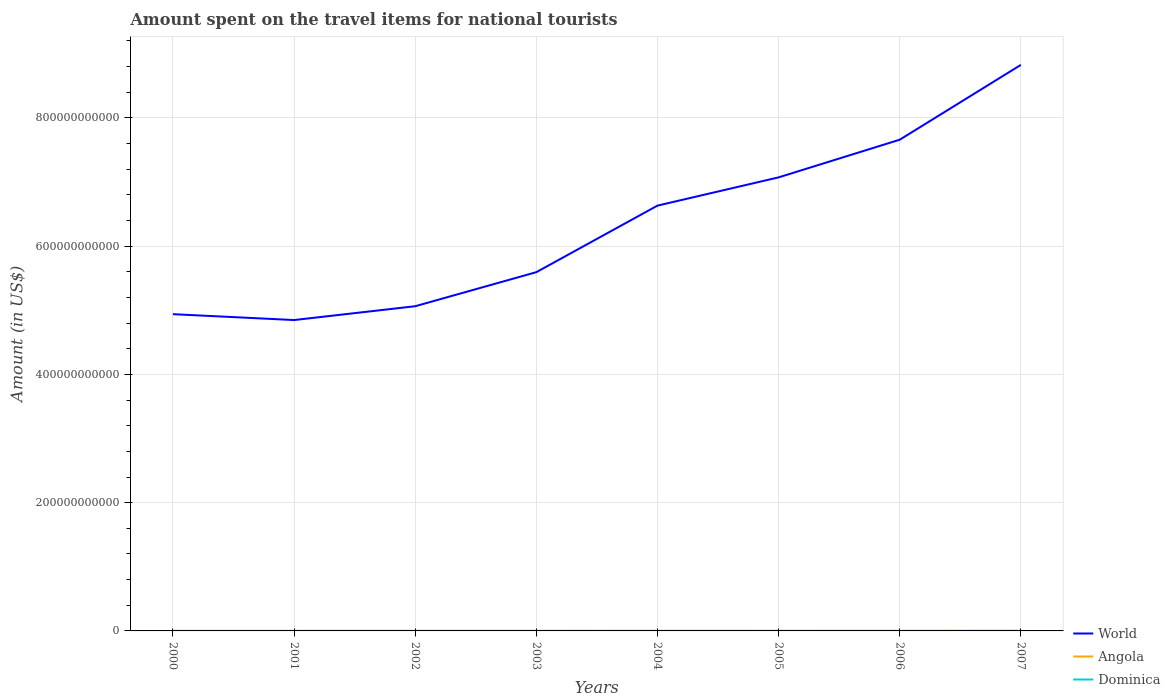Does the line corresponding to Angola intersect with the line corresponding to Dominica?
Your answer should be very brief. Yes. Across all years, what is the maximum amount spent on the travel items for national tourists in World?
Your response must be concise. 4.85e+11. What is the total amount spent on the travel items for national tourists in Angola in the graph?
Give a very brief answer. -9.00e+06. What is the difference between the highest and the second highest amount spent on the travel items for national tourists in World?
Make the answer very short. 3.98e+11. What is the difference between the highest and the lowest amount spent on the travel items for national tourists in World?
Offer a very short reply. 4. Is the amount spent on the travel items for national tourists in World strictly greater than the amount spent on the travel items for national tourists in Angola over the years?
Offer a very short reply. No. What is the difference between two consecutive major ticks on the Y-axis?
Provide a short and direct response. 2.00e+11. Does the graph contain grids?
Your answer should be very brief. Yes. How are the legend labels stacked?
Give a very brief answer. Vertical. What is the title of the graph?
Your answer should be compact. Amount spent on the travel items for national tourists. Does "Sweden" appear as one of the legend labels in the graph?
Your answer should be compact. No. What is the Amount (in US$) of World in 2000?
Provide a short and direct response. 4.94e+11. What is the Amount (in US$) of Angola in 2000?
Offer a very short reply. 1.80e+07. What is the Amount (in US$) in Dominica in 2000?
Your response must be concise. 4.80e+07. What is the Amount (in US$) of World in 2001?
Your answer should be very brief. 4.85e+11. What is the Amount (in US$) in Angola in 2001?
Offer a terse response. 2.20e+07. What is the Amount (in US$) in Dominica in 2001?
Your answer should be compact. 4.60e+07. What is the Amount (in US$) in World in 2002?
Give a very brief answer. 5.06e+11. What is the Amount (in US$) of Angola in 2002?
Keep it short and to the point. 3.70e+07. What is the Amount (in US$) of Dominica in 2002?
Keep it short and to the point. 4.60e+07. What is the Amount (in US$) in World in 2003?
Offer a terse response. 5.59e+11. What is the Amount (in US$) of Angola in 2003?
Keep it short and to the point. 4.90e+07. What is the Amount (in US$) in Dominica in 2003?
Provide a short and direct response. 5.20e+07. What is the Amount (in US$) in World in 2004?
Give a very brief answer. 6.63e+11. What is the Amount (in US$) of Angola in 2004?
Offer a terse response. 6.60e+07. What is the Amount (in US$) in Dominica in 2004?
Ensure brevity in your answer.  6.10e+07. What is the Amount (in US$) of World in 2005?
Provide a succinct answer. 7.07e+11. What is the Amount (in US$) of Angola in 2005?
Your answer should be compact. 8.80e+07. What is the Amount (in US$) of Dominica in 2005?
Offer a very short reply. 5.70e+07. What is the Amount (in US$) in World in 2006?
Give a very brief answer. 7.66e+11. What is the Amount (in US$) in Angola in 2006?
Ensure brevity in your answer.  7.50e+07. What is the Amount (in US$) in Dominica in 2006?
Your answer should be very brief. 7.20e+07. What is the Amount (in US$) of World in 2007?
Provide a short and direct response. 8.83e+11. What is the Amount (in US$) of Angola in 2007?
Keep it short and to the point. 2.25e+08. What is the Amount (in US$) in Dominica in 2007?
Provide a short and direct response. 7.40e+07. Across all years, what is the maximum Amount (in US$) in World?
Keep it short and to the point. 8.83e+11. Across all years, what is the maximum Amount (in US$) in Angola?
Your response must be concise. 2.25e+08. Across all years, what is the maximum Amount (in US$) in Dominica?
Keep it short and to the point. 7.40e+07. Across all years, what is the minimum Amount (in US$) of World?
Ensure brevity in your answer.  4.85e+11. Across all years, what is the minimum Amount (in US$) in Angola?
Give a very brief answer. 1.80e+07. Across all years, what is the minimum Amount (in US$) in Dominica?
Give a very brief answer. 4.60e+07. What is the total Amount (in US$) of World in the graph?
Provide a succinct answer. 5.06e+12. What is the total Amount (in US$) of Angola in the graph?
Provide a short and direct response. 5.80e+08. What is the total Amount (in US$) in Dominica in the graph?
Give a very brief answer. 4.56e+08. What is the difference between the Amount (in US$) of World in 2000 and that in 2001?
Make the answer very short. 9.15e+09. What is the difference between the Amount (in US$) of Dominica in 2000 and that in 2001?
Your answer should be compact. 2.00e+06. What is the difference between the Amount (in US$) in World in 2000 and that in 2002?
Give a very brief answer. -1.24e+1. What is the difference between the Amount (in US$) in Angola in 2000 and that in 2002?
Offer a terse response. -1.90e+07. What is the difference between the Amount (in US$) of Dominica in 2000 and that in 2002?
Provide a succinct answer. 2.00e+06. What is the difference between the Amount (in US$) in World in 2000 and that in 2003?
Your answer should be compact. -6.55e+1. What is the difference between the Amount (in US$) of Angola in 2000 and that in 2003?
Your response must be concise. -3.10e+07. What is the difference between the Amount (in US$) of Dominica in 2000 and that in 2003?
Offer a very short reply. -4.00e+06. What is the difference between the Amount (in US$) in World in 2000 and that in 2004?
Your response must be concise. -1.69e+11. What is the difference between the Amount (in US$) in Angola in 2000 and that in 2004?
Your answer should be very brief. -4.80e+07. What is the difference between the Amount (in US$) of Dominica in 2000 and that in 2004?
Your answer should be compact. -1.30e+07. What is the difference between the Amount (in US$) of World in 2000 and that in 2005?
Offer a terse response. -2.13e+11. What is the difference between the Amount (in US$) in Angola in 2000 and that in 2005?
Give a very brief answer. -7.00e+07. What is the difference between the Amount (in US$) of Dominica in 2000 and that in 2005?
Your answer should be compact. -9.00e+06. What is the difference between the Amount (in US$) of World in 2000 and that in 2006?
Give a very brief answer. -2.72e+11. What is the difference between the Amount (in US$) of Angola in 2000 and that in 2006?
Your answer should be compact. -5.70e+07. What is the difference between the Amount (in US$) in Dominica in 2000 and that in 2006?
Provide a short and direct response. -2.40e+07. What is the difference between the Amount (in US$) of World in 2000 and that in 2007?
Offer a terse response. -3.89e+11. What is the difference between the Amount (in US$) in Angola in 2000 and that in 2007?
Offer a terse response. -2.07e+08. What is the difference between the Amount (in US$) in Dominica in 2000 and that in 2007?
Give a very brief answer. -2.60e+07. What is the difference between the Amount (in US$) of World in 2001 and that in 2002?
Make the answer very short. -2.15e+1. What is the difference between the Amount (in US$) in Angola in 2001 and that in 2002?
Provide a succinct answer. -1.50e+07. What is the difference between the Amount (in US$) of Dominica in 2001 and that in 2002?
Your answer should be compact. 0. What is the difference between the Amount (in US$) in World in 2001 and that in 2003?
Your answer should be very brief. -7.47e+1. What is the difference between the Amount (in US$) of Angola in 2001 and that in 2003?
Make the answer very short. -2.70e+07. What is the difference between the Amount (in US$) in Dominica in 2001 and that in 2003?
Keep it short and to the point. -6.00e+06. What is the difference between the Amount (in US$) of World in 2001 and that in 2004?
Ensure brevity in your answer.  -1.78e+11. What is the difference between the Amount (in US$) of Angola in 2001 and that in 2004?
Make the answer very short. -4.40e+07. What is the difference between the Amount (in US$) of Dominica in 2001 and that in 2004?
Your response must be concise. -1.50e+07. What is the difference between the Amount (in US$) in World in 2001 and that in 2005?
Keep it short and to the point. -2.22e+11. What is the difference between the Amount (in US$) of Angola in 2001 and that in 2005?
Your answer should be very brief. -6.60e+07. What is the difference between the Amount (in US$) in Dominica in 2001 and that in 2005?
Give a very brief answer. -1.10e+07. What is the difference between the Amount (in US$) of World in 2001 and that in 2006?
Make the answer very short. -2.81e+11. What is the difference between the Amount (in US$) of Angola in 2001 and that in 2006?
Keep it short and to the point. -5.30e+07. What is the difference between the Amount (in US$) of Dominica in 2001 and that in 2006?
Make the answer very short. -2.60e+07. What is the difference between the Amount (in US$) of World in 2001 and that in 2007?
Keep it short and to the point. -3.98e+11. What is the difference between the Amount (in US$) in Angola in 2001 and that in 2007?
Your answer should be compact. -2.03e+08. What is the difference between the Amount (in US$) in Dominica in 2001 and that in 2007?
Provide a short and direct response. -2.80e+07. What is the difference between the Amount (in US$) in World in 2002 and that in 2003?
Offer a very short reply. -5.31e+1. What is the difference between the Amount (in US$) in Angola in 2002 and that in 2003?
Your answer should be very brief. -1.20e+07. What is the difference between the Amount (in US$) in Dominica in 2002 and that in 2003?
Your answer should be very brief. -6.00e+06. What is the difference between the Amount (in US$) in World in 2002 and that in 2004?
Offer a very short reply. -1.57e+11. What is the difference between the Amount (in US$) of Angola in 2002 and that in 2004?
Your answer should be compact. -2.90e+07. What is the difference between the Amount (in US$) in Dominica in 2002 and that in 2004?
Keep it short and to the point. -1.50e+07. What is the difference between the Amount (in US$) in World in 2002 and that in 2005?
Your response must be concise. -2.01e+11. What is the difference between the Amount (in US$) of Angola in 2002 and that in 2005?
Make the answer very short. -5.10e+07. What is the difference between the Amount (in US$) of Dominica in 2002 and that in 2005?
Your answer should be compact. -1.10e+07. What is the difference between the Amount (in US$) of World in 2002 and that in 2006?
Your answer should be very brief. -2.60e+11. What is the difference between the Amount (in US$) of Angola in 2002 and that in 2006?
Give a very brief answer. -3.80e+07. What is the difference between the Amount (in US$) of Dominica in 2002 and that in 2006?
Offer a terse response. -2.60e+07. What is the difference between the Amount (in US$) of World in 2002 and that in 2007?
Your response must be concise. -3.76e+11. What is the difference between the Amount (in US$) of Angola in 2002 and that in 2007?
Give a very brief answer. -1.88e+08. What is the difference between the Amount (in US$) in Dominica in 2002 and that in 2007?
Make the answer very short. -2.80e+07. What is the difference between the Amount (in US$) of World in 2003 and that in 2004?
Ensure brevity in your answer.  -1.04e+11. What is the difference between the Amount (in US$) of Angola in 2003 and that in 2004?
Provide a succinct answer. -1.70e+07. What is the difference between the Amount (in US$) in Dominica in 2003 and that in 2004?
Your answer should be very brief. -9.00e+06. What is the difference between the Amount (in US$) in World in 2003 and that in 2005?
Keep it short and to the point. -1.48e+11. What is the difference between the Amount (in US$) of Angola in 2003 and that in 2005?
Provide a succinct answer. -3.90e+07. What is the difference between the Amount (in US$) in Dominica in 2003 and that in 2005?
Your answer should be compact. -5.00e+06. What is the difference between the Amount (in US$) of World in 2003 and that in 2006?
Your answer should be very brief. -2.07e+11. What is the difference between the Amount (in US$) in Angola in 2003 and that in 2006?
Offer a terse response. -2.60e+07. What is the difference between the Amount (in US$) in Dominica in 2003 and that in 2006?
Offer a terse response. -2.00e+07. What is the difference between the Amount (in US$) in World in 2003 and that in 2007?
Provide a short and direct response. -3.23e+11. What is the difference between the Amount (in US$) in Angola in 2003 and that in 2007?
Offer a very short reply. -1.76e+08. What is the difference between the Amount (in US$) in Dominica in 2003 and that in 2007?
Your answer should be very brief. -2.20e+07. What is the difference between the Amount (in US$) of World in 2004 and that in 2005?
Ensure brevity in your answer.  -4.40e+1. What is the difference between the Amount (in US$) of Angola in 2004 and that in 2005?
Make the answer very short. -2.20e+07. What is the difference between the Amount (in US$) in World in 2004 and that in 2006?
Your answer should be compact. -1.03e+11. What is the difference between the Amount (in US$) of Angola in 2004 and that in 2006?
Ensure brevity in your answer.  -9.00e+06. What is the difference between the Amount (in US$) of Dominica in 2004 and that in 2006?
Offer a terse response. -1.10e+07. What is the difference between the Amount (in US$) of World in 2004 and that in 2007?
Keep it short and to the point. -2.19e+11. What is the difference between the Amount (in US$) of Angola in 2004 and that in 2007?
Give a very brief answer. -1.59e+08. What is the difference between the Amount (in US$) of Dominica in 2004 and that in 2007?
Provide a short and direct response. -1.30e+07. What is the difference between the Amount (in US$) of World in 2005 and that in 2006?
Ensure brevity in your answer.  -5.87e+1. What is the difference between the Amount (in US$) of Angola in 2005 and that in 2006?
Your answer should be compact. 1.30e+07. What is the difference between the Amount (in US$) in Dominica in 2005 and that in 2006?
Provide a short and direct response. -1.50e+07. What is the difference between the Amount (in US$) in World in 2005 and that in 2007?
Offer a very short reply. -1.75e+11. What is the difference between the Amount (in US$) of Angola in 2005 and that in 2007?
Your answer should be compact. -1.37e+08. What is the difference between the Amount (in US$) of Dominica in 2005 and that in 2007?
Provide a succinct answer. -1.70e+07. What is the difference between the Amount (in US$) in World in 2006 and that in 2007?
Give a very brief answer. -1.17e+11. What is the difference between the Amount (in US$) in Angola in 2006 and that in 2007?
Provide a short and direct response. -1.50e+08. What is the difference between the Amount (in US$) of Dominica in 2006 and that in 2007?
Ensure brevity in your answer.  -2.00e+06. What is the difference between the Amount (in US$) in World in 2000 and the Amount (in US$) in Angola in 2001?
Give a very brief answer. 4.94e+11. What is the difference between the Amount (in US$) in World in 2000 and the Amount (in US$) in Dominica in 2001?
Provide a short and direct response. 4.94e+11. What is the difference between the Amount (in US$) in Angola in 2000 and the Amount (in US$) in Dominica in 2001?
Offer a very short reply. -2.80e+07. What is the difference between the Amount (in US$) in World in 2000 and the Amount (in US$) in Angola in 2002?
Provide a succinct answer. 4.94e+11. What is the difference between the Amount (in US$) in World in 2000 and the Amount (in US$) in Dominica in 2002?
Your answer should be compact. 4.94e+11. What is the difference between the Amount (in US$) in Angola in 2000 and the Amount (in US$) in Dominica in 2002?
Offer a very short reply. -2.80e+07. What is the difference between the Amount (in US$) in World in 2000 and the Amount (in US$) in Angola in 2003?
Your answer should be very brief. 4.94e+11. What is the difference between the Amount (in US$) of World in 2000 and the Amount (in US$) of Dominica in 2003?
Offer a terse response. 4.94e+11. What is the difference between the Amount (in US$) in Angola in 2000 and the Amount (in US$) in Dominica in 2003?
Provide a succinct answer. -3.40e+07. What is the difference between the Amount (in US$) in World in 2000 and the Amount (in US$) in Angola in 2004?
Your answer should be compact. 4.94e+11. What is the difference between the Amount (in US$) in World in 2000 and the Amount (in US$) in Dominica in 2004?
Offer a very short reply. 4.94e+11. What is the difference between the Amount (in US$) in Angola in 2000 and the Amount (in US$) in Dominica in 2004?
Offer a very short reply. -4.30e+07. What is the difference between the Amount (in US$) of World in 2000 and the Amount (in US$) of Angola in 2005?
Offer a very short reply. 4.94e+11. What is the difference between the Amount (in US$) in World in 2000 and the Amount (in US$) in Dominica in 2005?
Your response must be concise. 4.94e+11. What is the difference between the Amount (in US$) in Angola in 2000 and the Amount (in US$) in Dominica in 2005?
Offer a very short reply. -3.90e+07. What is the difference between the Amount (in US$) in World in 2000 and the Amount (in US$) in Angola in 2006?
Provide a short and direct response. 4.94e+11. What is the difference between the Amount (in US$) of World in 2000 and the Amount (in US$) of Dominica in 2006?
Offer a very short reply. 4.94e+11. What is the difference between the Amount (in US$) of Angola in 2000 and the Amount (in US$) of Dominica in 2006?
Offer a terse response. -5.40e+07. What is the difference between the Amount (in US$) of World in 2000 and the Amount (in US$) of Angola in 2007?
Make the answer very short. 4.94e+11. What is the difference between the Amount (in US$) of World in 2000 and the Amount (in US$) of Dominica in 2007?
Your answer should be compact. 4.94e+11. What is the difference between the Amount (in US$) in Angola in 2000 and the Amount (in US$) in Dominica in 2007?
Offer a very short reply. -5.60e+07. What is the difference between the Amount (in US$) of World in 2001 and the Amount (in US$) of Angola in 2002?
Give a very brief answer. 4.85e+11. What is the difference between the Amount (in US$) in World in 2001 and the Amount (in US$) in Dominica in 2002?
Offer a very short reply. 4.85e+11. What is the difference between the Amount (in US$) of Angola in 2001 and the Amount (in US$) of Dominica in 2002?
Your answer should be very brief. -2.40e+07. What is the difference between the Amount (in US$) in World in 2001 and the Amount (in US$) in Angola in 2003?
Your response must be concise. 4.85e+11. What is the difference between the Amount (in US$) of World in 2001 and the Amount (in US$) of Dominica in 2003?
Offer a terse response. 4.85e+11. What is the difference between the Amount (in US$) in Angola in 2001 and the Amount (in US$) in Dominica in 2003?
Offer a very short reply. -3.00e+07. What is the difference between the Amount (in US$) of World in 2001 and the Amount (in US$) of Angola in 2004?
Your answer should be compact. 4.85e+11. What is the difference between the Amount (in US$) of World in 2001 and the Amount (in US$) of Dominica in 2004?
Offer a terse response. 4.85e+11. What is the difference between the Amount (in US$) of Angola in 2001 and the Amount (in US$) of Dominica in 2004?
Offer a terse response. -3.90e+07. What is the difference between the Amount (in US$) of World in 2001 and the Amount (in US$) of Angola in 2005?
Offer a terse response. 4.85e+11. What is the difference between the Amount (in US$) in World in 2001 and the Amount (in US$) in Dominica in 2005?
Provide a short and direct response. 4.85e+11. What is the difference between the Amount (in US$) in Angola in 2001 and the Amount (in US$) in Dominica in 2005?
Provide a succinct answer. -3.50e+07. What is the difference between the Amount (in US$) of World in 2001 and the Amount (in US$) of Angola in 2006?
Your answer should be compact. 4.85e+11. What is the difference between the Amount (in US$) of World in 2001 and the Amount (in US$) of Dominica in 2006?
Keep it short and to the point. 4.85e+11. What is the difference between the Amount (in US$) of Angola in 2001 and the Amount (in US$) of Dominica in 2006?
Your answer should be compact. -5.00e+07. What is the difference between the Amount (in US$) of World in 2001 and the Amount (in US$) of Angola in 2007?
Make the answer very short. 4.85e+11. What is the difference between the Amount (in US$) of World in 2001 and the Amount (in US$) of Dominica in 2007?
Keep it short and to the point. 4.85e+11. What is the difference between the Amount (in US$) in Angola in 2001 and the Amount (in US$) in Dominica in 2007?
Offer a terse response. -5.20e+07. What is the difference between the Amount (in US$) of World in 2002 and the Amount (in US$) of Angola in 2003?
Provide a short and direct response. 5.06e+11. What is the difference between the Amount (in US$) of World in 2002 and the Amount (in US$) of Dominica in 2003?
Give a very brief answer. 5.06e+11. What is the difference between the Amount (in US$) in Angola in 2002 and the Amount (in US$) in Dominica in 2003?
Provide a succinct answer. -1.50e+07. What is the difference between the Amount (in US$) in World in 2002 and the Amount (in US$) in Angola in 2004?
Keep it short and to the point. 5.06e+11. What is the difference between the Amount (in US$) of World in 2002 and the Amount (in US$) of Dominica in 2004?
Your answer should be very brief. 5.06e+11. What is the difference between the Amount (in US$) in Angola in 2002 and the Amount (in US$) in Dominica in 2004?
Keep it short and to the point. -2.40e+07. What is the difference between the Amount (in US$) in World in 2002 and the Amount (in US$) in Angola in 2005?
Offer a very short reply. 5.06e+11. What is the difference between the Amount (in US$) of World in 2002 and the Amount (in US$) of Dominica in 2005?
Your response must be concise. 5.06e+11. What is the difference between the Amount (in US$) of Angola in 2002 and the Amount (in US$) of Dominica in 2005?
Your answer should be compact. -2.00e+07. What is the difference between the Amount (in US$) in World in 2002 and the Amount (in US$) in Angola in 2006?
Provide a succinct answer. 5.06e+11. What is the difference between the Amount (in US$) in World in 2002 and the Amount (in US$) in Dominica in 2006?
Keep it short and to the point. 5.06e+11. What is the difference between the Amount (in US$) in Angola in 2002 and the Amount (in US$) in Dominica in 2006?
Make the answer very short. -3.50e+07. What is the difference between the Amount (in US$) of World in 2002 and the Amount (in US$) of Angola in 2007?
Offer a very short reply. 5.06e+11. What is the difference between the Amount (in US$) in World in 2002 and the Amount (in US$) in Dominica in 2007?
Your answer should be compact. 5.06e+11. What is the difference between the Amount (in US$) in Angola in 2002 and the Amount (in US$) in Dominica in 2007?
Your answer should be compact. -3.70e+07. What is the difference between the Amount (in US$) in World in 2003 and the Amount (in US$) in Angola in 2004?
Your answer should be compact. 5.59e+11. What is the difference between the Amount (in US$) in World in 2003 and the Amount (in US$) in Dominica in 2004?
Offer a very short reply. 5.59e+11. What is the difference between the Amount (in US$) in Angola in 2003 and the Amount (in US$) in Dominica in 2004?
Keep it short and to the point. -1.20e+07. What is the difference between the Amount (in US$) in World in 2003 and the Amount (in US$) in Angola in 2005?
Give a very brief answer. 5.59e+11. What is the difference between the Amount (in US$) of World in 2003 and the Amount (in US$) of Dominica in 2005?
Provide a succinct answer. 5.59e+11. What is the difference between the Amount (in US$) of Angola in 2003 and the Amount (in US$) of Dominica in 2005?
Make the answer very short. -8.00e+06. What is the difference between the Amount (in US$) in World in 2003 and the Amount (in US$) in Angola in 2006?
Give a very brief answer. 5.59e+11. What is the difference between the Amount (in US$) of World in 2003 and the Amount (in US$) of Dominica in 2006?
Ensure brevity in your answer.  5.59e+11. What is the difference between the Amount (in US$) of Angola in 2003 and the Amount (in US$) of Dominica in 2006?
Provide a succinct answer. -2.30e+07. What is the difference between the Amount (in US$) of World in 2003 and the Amount (in US$) of Angola in 2007?
Make the answer very short. 5.59e+11. What is the difference between the Amount (in US$) in World in 2003 and the Amount (in US$) in Dominica in 2007?
Your answer should be very brief. 5.59e+11. What is the difference between the Amount (in US$) in Angola in 2003 and the Amount (in US$) in Dominica in 2007?
Provide a short and direct response. -2.50e+07. What is the difference between the Amount (in US$) in World in 2004 and the Amount (in US$) in Angola in 2005?
Offer a very short reply. 6.63e+11. What is the difference between the Amount (in US$) of World in 2004 and the Amount (in US$) of Dominica in 2005?
Ensure brevity in your answer.  6.63e+11. What is the difference between the Amount (in US$) of Angola in 2004 and the Amount (in US$) of Dominica in 2005?
Offer a very short reply. 9.00e+06. What is the difference between the Amount (in US$) of World in 2004 and the Amount (in US$) of Angola in 2006?
Ensure brevity in your answer.  6.63e+11. What is the difference between the Amount (in US$) in World in 2004 and the Amount (in US$) in Dominica in 2006?
Provide a short and direct response. 6.63e+11. What is the difference between the Amount (in US$) of Angola in 2004 and the Amount (in US$) of Dominica in 2006?
Provide a short and direct response. -6.00e+06. What is the difference between the Amount (in US$) of World in 2004 and the Amount (in US$) of Angola in 2007?
Your response must be concise. 6.63e+11. What is the difference between the Amount (in US$) in World in 2004 and the Amount (in US$) in Dominica in 2007?
Provide a succinct answer. 6.63e+11. What is the difference between the Amount (in US$) of Angola in 2004 and the Amount (in US$) of Dominica in 2007?
Provide a short and direct response. -8.00e+06. What is the difference between the Amount (in US$) of World in 2005 and the Amount (in US$) of Angola in 2006?
Offer a very short reply. 7.07e+11. What is the difference between the Amount (in US$) of World in 2005 and the Amount (in US$) of Dominica in 2006?
Your answer should be compact. 7.07e+11. What is the difference between the Amount (in US$) in Angola in 2005 and the Amount (in US$) in Dominica in 2006?
Your response must be concise. 1.60e+07. What is the difference between the Amount (in US$) of World in 2005 and the Amount (in US$) of Angola in 2007?
Your answer should be very brief. 7.07e+11. What is the difference between the Amount (in US$) of World in 2005 and the Amount (in US$) of Dominica in 2007?
Ensure brevity in your answer.  7.07e+11. What is the difference between the Amount (in US$) in Angola in 2005 and the Amount (in US$) in Dominica in 2007?
Your answer should be very brief. 1.40e+07. What is the difference between the Amount (in US$) in World in 2006 and the Amount (in US$) in Angola in 2007?
Your response must be concise. 7.66e+11. What is the difference between the Amount (in US$) of World in 2006 and the Amount (in US$) of Dominica in 2007?
Ensure brevity in your answer.  7.66e+11. What is the average Amount (in US$) in World per year?
Your response must be concise. 6.33e+11. What is the average Amount (in US$) of Angola per year?
Provide a succinct answer. 7.25e+07. What is the average Amount (in US$) of Dominica per year?
Your answer should be compact. 5.70e+07. In the year 2000, what is the difference between the Amount (in US$) of World and Amount (in US$) of Angola?
Offer a terse response. 4.94e+11. In the year 2000, what is the difference between the Amount (in US$) in World and Amount (in US$) in Dominica?
Keep it short and to the point. 4.94e+11. In the year 2000, what is the difference between the Amount (in US$) of Angola and Amount (in US$) of Dominica?
Offer a terse response. -3.00e+07. In the year 2001, what is the difference between the Amount (in US$) of World and Amount (in US$) of Angola?
Your answer should be compact. 4.85e+11. In the year 2001, what is the difference between the Amount (in US$) in World and Amount (in US$) in Dominica?
Ensure brevity in your answer.  4.85e+11. In the year 2001, what is the difference between the Amount (in US$) in Angola and Amount (in US$) in Dominica?
Make the answer very short. -2.40e+07. In the year 2002, what is the difference between the Amount (in US$) of World and Amount (in US$) of Angola?
Keep it short and to the point. 5.06e+11. In the year 2002, what is the difference between the Amount (in US$) in World and Amount (in US$) in Dominica?
Keep it short and to the point. 5.06e+11. In the year 2002, what is the difference between the Amount (in US$) in Angola and Amount (in US$) in Dominica?
Ensure brevity in your answer.  -9.00e+06. In the year 2003, what is the difference between the Amount (in US$) in World and Amount (in US$) in Angola?
Give a very brief answer. 5.59e+11. In the year 2003, what is the difference between the Amount (in US$) of World and Amount (in US$) of Dominica?
Keep it short and to the point. 5.59e+11. In the year 2003, what is the difference between the Amount (in US$) in Angola and Amount (in US$) in Dominica?
Your response must be concise. -3.00e+06. In the year 2004, what is the difference between the Amount (in US$) of World and Amount (in US$) of Angola?
Make the answer very short. 6.63e+11. In the year 2004, what is the difference between the Amount (in US$) in World and Amount (in US$) in Dominica?
Your response must be concise. 6.63e+11. In the year 2004, what is the difference between the Amount (in US$) of Angola and Amount (in US$) of Dominica?
Your response must be concise. 5.00e+06. In the year 2005, what is the difference between the Amount (in US$) of World and Amount (in US$) of Angola?
Keep it short and to the point. 7.07e+11. In the year 2005, what is the difference between the Amount (in US$) in World and Amount (in US$) in Dominica?
Your response must be concise. 7.07e+11. In the year 2005, what is the difference between the Amount (in US$) in Angola and Amount (in US$) in Dominica?
Offer a very short reply. 3.10e+07. In the year 2006, what is the difference between the Amount (in US$) in World and Amount (in US$) in Angola?
Offer a terse response. 7.66e+11. In the year 2006, what is the difference between the Amount (in US$) of World and Amount (in US$) of Dominica?
Your answer should be very brief. 7.66e+11. In the year 2007, what is the difference between the Amount (in US$) in World and Amount (in US$) in Angola?
Provide a succinct answer. 8.82e+11. In the year 2007, what is the difference between the Amount (in US$) of World and Amount (in US$) of Dominica?
Provide a short and direct response. 8.83e+11. In the year 2007, what is the difference between the Amount (in US$) of Angola and Amount (in US$) of Dominica?
Offer a very short reply. 1.51e+08. What is the ratio of the Amount (in US$) in World in 2000 to that in 2001?
Provide a short and direct response. 1.02. What is the ratio of the Amount (in US$) in Angola in 2000 to that in 2001?
Keep it short and to the point. 0.82. What is the ratio of the Amount (in US$) of Dominica in 2000 to that in 2001?
Provide a short and direct response. 1.04. What is the ratio of the Amount (in US$) in World in 2000 to that in 2002?
Make the answer very short. 0.98. What is the ratio of the Amount (in US$) of Angola in 2000 to that in 2002?
Keep it short and to the point. 0.49. What is the ratio of the Amount (in US$) in Dominica in 2000 to that in 2002?
Your answer should be compact. 1.04. What is the ratio of the Amount (in US$) of World in 2000 to that in 2003?
Make the answer very short. 0.88. What is the ratio of the Amount (in US$) of Angola in 2000 to that in 2003?
Your answer should be very brief. 0.37. What is the ratio of the Amount (in US$) in Dominica in 2000 to that in 2003?
Provide a succinct answer. 0.92. What is the ratio of the Amount (in US$) in World in 2000 to that in 2004?
Offer a very short reply. 0.74. What is the ratio of the Amount (in US$) of Angola in 2000 to that in 2004?
Make the answer very short. 0.27. What is the ratio of the Amount (in US$) in Dominica in 2000 to that in 2004?
Keep it short and to the point. 0.79. What is the ratio of the Amount (in US$) of World in 2000 to that in 2005?
Your answer should be compact. 0.7. What is the ratio of the Amount (in US$) in Angola in 2000 to that in 2005?
Your answer should be very brief. 0.2. What is the ratio of the Amount (in US$) in Dominica in 2000 to that in 2005?
Make the answer very short. 0.84. What is the ratio of the Amount (in US$) of World in 2000 to that in 2006?
Give a very brief answer. 0.64. What is the ratio of the Amount (in US$) in Angola in 2000 to that in 2006?
Keep it short and to the point. 0.24. What is the ratio of the Amount (in US$) in World in 2000 to that in 2007?
Offer a terse response. 0.56. What is the ratio of the Amount (in US$) of Angola in 2000 to that in 2007?
Offer a very short reply. 0.08. What is the ratio of the Amount (in US$) of Dominica in 2000 to that in 2007?
Offer a very short reply. 0.65. What is the ratio of the Amount (in US$) in World in 2001 to that in 2002?
Make the answer very short. 0.96. What is the ratio of the Amount (in US$) of Angola in 2001 to that in 2002?
Offer a terse response. 0.59. What is the ratio of the Amount (in US$) of World in 2001 to that in 2003?
Your answer should be compact. 0.87. What is the ratio of the Amount (in US$) of Angola in 2001 to that in 2003?
Your answer should be compact. 0.45. What is the ratio of the Amount (in US$) of Dominica in 2001 to that in 2003?
Keep it short and to the point. 0.88. What is the ratio of the Amount (in US$) of World in 2001 to that in 2004?
Your answer should be compact. 0.73. What is the ratio of the Amount (in US$) in Angola in 2001 to that in 2004?
Provide a succinct answer. 0.33. What is the ratio of the Amount (in US$) of Dominica in 2001 to that in 2004?
Offer a terse response. 0.75. What is the ratio of the Amount (in US$) of World in 2001 to that in 2005?
Offer a terse response. 0.69. What is the ratio of the Amount (in US$) in Dominica in 2001 to that in 2005?
Offer a very short reply. 0.81. What is the ratio of the Amount (in US$) in World in 2001 to that in 2006?
Keep it short and to the point. 0.63. What is the ratio of the Amount (in US$) in Angola in 2001 to that in 2006?
Keep it short and to the point. 0.29. What is the ratio of the Amount (in US$) in Dominica in 2001 to that in 2006?
Provide a short and direct response. 0.64. What is the ratio of the Amount (in US$) of World in 2001 to that in 2007?
Ensure brevity in your answer.  0.55. What is the ratio of the Amount (in US$) in Angola in 2001 to that in 2007?
Give a very brief answer. 0.1. What is the ratio of the Amount (in US$) of Dominica in 2001 to that in 2007?
Ensure brevity in your answer.  0.62. What is the ratio of the Amount (in US$) in World in 2002 to that in 2003?
Provide a succinct answer. 0.91. What is the ratio of the Amount (in US$) of Angola in 2002 to that in 2003?
Your response must be concise. 0.76. What is the ratio of the Amount (in US$) in Dominica in 2002 to that in 2003?
Provide a short and direct response. 0.88. What is the ratio of the Amount (in US$) of World in 2002 to that in 2004?
Offer a very short reply. 0.76. What is the ratio of the Amount (in US$) of Angola in 2002 to that in 2004?
Provide a succinct answer. 0.56. What is the ratio of the Amount (in US$) of Dominica in 2002 to that in 2004?
Your response must be concise. 0.75. What is the ratio of the Amount (in US$) in World in 2002 to that in 2005?
Ensure brevity in your answer.  0.72. What is the ratio of the Amount (in US$) in Angola in 2002 to that in 2005?
Your response must be concise. 0.42. What is the ratio of the Amount (in US$) in Dominica in 2002 to that in 2005?
Provide a succinct answer. 0.81. What is the ratio of the Amount (in US$) in World in 2002 to that in 2006?
Your answer should be very brief. 0.66. What is the ratio of the Amount (in US$) of Angola in 2002 to that in 2006?
Your response must be concise. 0.49. What is the ratio of the Amount (in US$) of Dominica in 2002 to that in 2006?
Offer a very short reply. 0.64. What is the ratio of the Amount (in US$) in World in 2002 to that in 2007?
Your response must be concise. 0.57. What is the ratio of the Amount (in US$) in Angola in 2002 to that in 2007?
Make the answer very short. 0.16. What is the ratio of the Amount (in US$) of Dominica in 2002 to that in 2007?
Offer a terse response. 0.62. What is the ratio of the Amount (in US$) of World in 2003 to that in 2004?
Your answer should be very brief. 0.84. What is the ratio of the Amount (in US$) in Angola in 2003 to that in 2004?
Ensure brevity in your answer.  0.74. What is the ratio of the Amount (in US$) in Dominica in 2003 to that in 2004?
Offer a terse response. 0.85. What is the ratio of the Amount (in US$) of World in 2003 to that in 2005?
Keep it short and to the point. 0.79. What is the ratio of the Amount (in US$) in Angola in 2003 to that in 2005?
Offer a terse response. 0.56. What is the ratio of the Amount (in US$) in Dominica in 2003 to that in 2005?
Your answer should be very brief. 0.91. What is the ratio of the Amount (in US$) of World in 2003 to that in 2006?
Ensure brevity in your answer.  0.73. What is the ratio of the Amount (in US$) in Angola in 2003 to that in 2006?
Offer a terse response. 0.65. What is the ratio of the Amount (in US$) of Dominica in 2003 to that in 2006?
Ensure brevity in your answer.  0.72. What is the ratio of the Amount (in US$) of World in 2003 to that in 2007?
Keep it short and to the point. 0.63. What is the ratio of the Amount (in US$) of Angola in 2003 to that in 2007?
Give a very brief answer. 0.22. What is the ratio of the Amount (in US$) of Dominica in 2003 to that in 2007?
Ensure brevity in your answer.  0.7. What is the ratio of the Amount (in US$) of World in 2004 to that in 2005?
Make the answer very short. 0.94. What is the ratio of the Amount (in US$) of Dominica in 2004 to that in 2005?
Ensure brevity in your answer.  1.07. What is the ratio of the Amount (in US$) in World in 2004 to that in 2006?
Your answer should be very brief. 0.87. What is the ratio of the Amount (in US$) of Angola in 2004 to that in 2006?
Your answer should be very brief. 0.88. What is the ratio of the Amount (in US$) in Dominica in 2004 to that in 2006?
Make the answer very short. 0.85. What is the ratio of the Amount (in US$) of World in 2004 to that in 2007?
Keep it short and to the point. 0.75. What is the ratio of the Amount (in US$) of Angola in 2004 to that in 2007?
Offer a very short reply. 0.29. What is the ratio of the Amount (in US$) of Dominica in 2004 to that in 2007?
Your response must be concise. 0.82. What is the ratio of the Amount (in US$) of World in 2005 to that in 2006?
Your answer should be compact. 0.92. What is the ratio of the Amount (in US$) in Angola in 2005 to that in 2006?
Your answer should be compact. 1.17. What is the ratio of the Amount (in US$) of Dominica in 2005 to that in 2006?
Provide a short and direct response. 0.79. What is the ratio of the Amount (in US$) in World in 2005 to that in 2007?
Keep it short and to the point. 0.8. What is the ratio of the Amount (in US$) of Angola in 2005 to that in 2007?
Keep it short and to the point. 0.39. What is the ratio of the Amount (in US$) of Dominica in 2005 to that in 2007?
Make the answer very short. 0.77. What is the ratio of the Amount (in US$) in World in 2006 to that in 2007?
Provide a short and direct response. 0.87. What is the ratio of the Amount (in US$) of Angola in 2006 to that in 2007?
Ensure brevity in your answer.  0.33. What is the difference between the highest and the second highest Amount (in US$) in World?
Ensure brevity in your answer.  1.17e+11. What is the difference between the highest and the second highest Amount (in US$) in Angola?
Give a very brief answer. 1.37e+08. What is the difference between the highest and the second highest Amount (in US$) in Dominica?
Offer a terse response. 2.00e+06. What is the difference between the highest and the lowest Amount (in US$) of World?
Your answer should be compact. 3.98e+11. What is the difference between the highest and the lowest Amount (in US$) in Angola?
Your answer should be compact. 2.07e+08. What is the difference between the highest and the lowest Amount (in US$) of Dominica?
Offer a very short reply. 2.80e+07. 